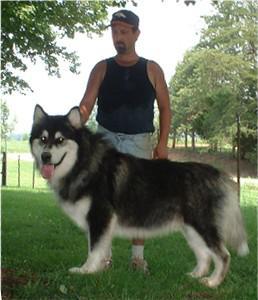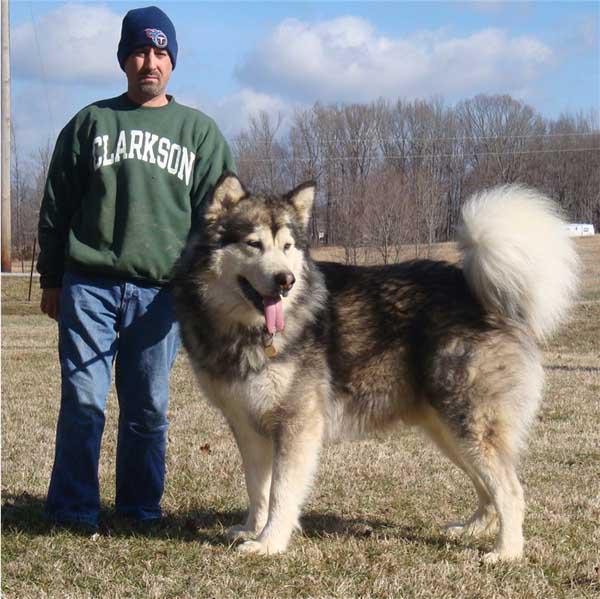The first image is the image on the left, the second image is the image on the right. Analyze the images presented: Is the assertion "There are exactly two dogs and two people." valid? Answer yes or no. Yes. 